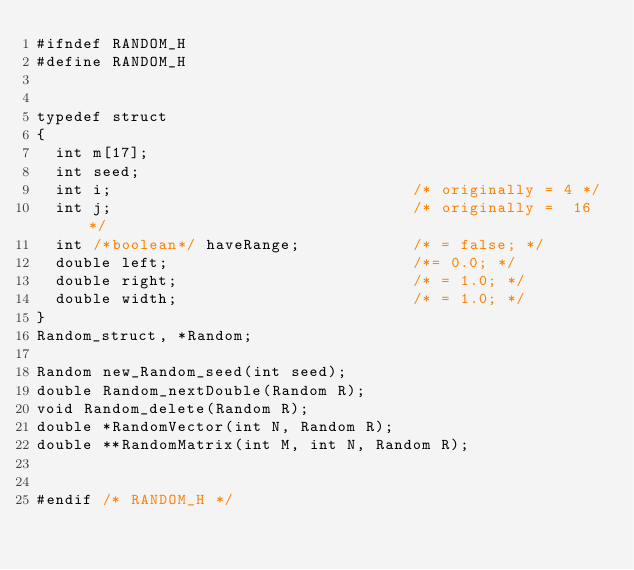Convert code to text. <code><loc_0><loc_0><loc_500><loc_500><_C_>#ifndef RANDOM_H
#define RANDOM_H


typedef struct
{
  int m[17];                        
  int seed;                             
  int i;                                /* originally = 4 */
  int j;                                /* originally =  16 */
  int /*boolean*/ haveRange;            /* = false; */
  double left;                          /*= 0.0; */
  double right;                         /* = 1.0; */
  double width;                         /* = 1.0; */
}
Random_struct, *Random;

Random new_Random_seed(int seed);
double Random_nextDouble(Random R);
void Random_delete(Random R);
double *RandomVector(int N, Random R);
double **RandomMatrix(int M, int N, Random R);


#endif /* RANDOM_H */
</code> 